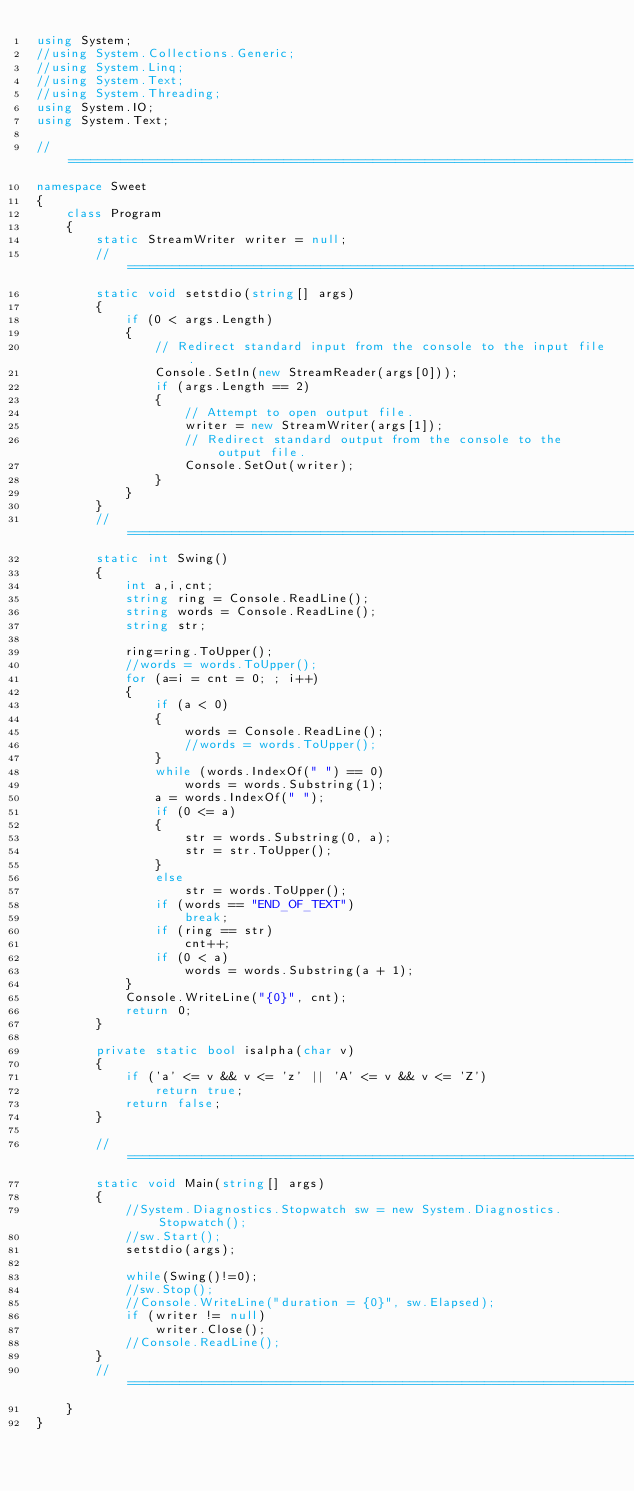<code> <loc_0><loc_0><loc_500><loc_500><_C#_>using System;
//using System.Collections.Generic;
//using System.Linq;
//using System.Text;
//using System.Threading;
using System.IO;
using System.Text;

//============================================================================
namespace Sweet
{
    class Program
    {
        static StreamWriter writer = null;
        //============================================================================
        static void setstdio(string[] args)
        {
            if (0 < args.Length)
            {
                // Redirect standard input from the console to the input file.
                Console.SetIn(new StreamReader(args[0]));
                if (args.Length == 2)
                {
                    // Attempt to open output file.
                    writer = new StreamWriter(args[1]);
                    // Redirect standard output from the console to the output file.
                    Console.SetOut(writer);
                }
            }
        }
        //============================================================================
        static int Swing()
        {
            int a,i,cnt;
            string ring = Console.ReadLine();
            string words = Console.ReadLine();
            string str;

            ring=ring.ToUpper();
            //words = words.ToUpper();
            for (a=i = cnt = 0; ; i++)
            {
                if (a < 0)
                {
                    words = Console.ReadLine();
                    //words = words.ToUpper();
                }
                while (words.IndexOf(" ") == 0)
                    words = words.Substring(1);
                a = words.IndexOf(" ");
                if (0 <= a)
                {
                    str = words.Substring(0, a);
                    str = str.ToUpper();
                }
                else
                    str = words.ToUpper();
                if (words == "END_OF_TEXT")
                    break;
                if (ring == str)
                    cnt++;
                if (0 < a)
                    words = words.Substring(a + 1);
            }
            Console.WriteLine("{0}", cnt);
            return 0;
        }

        private static bool isalpha(char v)
        {
            if ('a' <= v && v <= 'z' || 'A' <= v && v <= 'Z')
                return true;
            return false;
        }

        //============================================================================
        static void Main(string[] args)
        {
            //System.Diagnostics.Stopwatch sw = new System.Diagnostics.Stopwatch();
            //sw.Start();
            setstdio(args);

            while(Swing()!=0);
            //sw.Stop();
            //Console.WriteLine("duration = {0}", sw.Elapsed);
            if (writer != null)
                writer.Close();
            //Console.ReadLine();
        }
        //============================================================================
    }
}</code> 